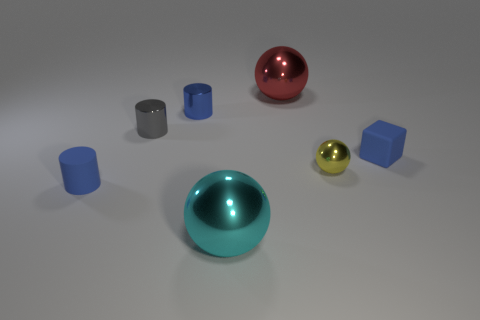What number of cyan things are either big metal blocks or big spheres?
Offer a very short reply. 1. What is the shape of the rubber thing that is the same color as the tiny rubber block?
Provide a short and direct response. Cylinder. Is there any other thing that is made of the same material as the red ball?
Your response must be concise. Yes. Do the object that is in front of the small matte cylinder and the yellow metallic thing behind the matte cylinder have the same shape?
Your answer should be compact. Yes. What number of small rubber objects are there?
Offer a terse response. 2. The large object that is made of the same material as the red ball is what shape?
Offer a terse response. Sphere. Are there any other things that are the same color as the small cube?
Give a very brief answer. Yes. There is a rubber cylinder; is it the same color as the block that is right of the tiny blue metal object?
Provide a short and direct response. Yes. Are there fewer red shiny balls in front of the red metallic object than blue shiny objects?
Ensure brevity in your answer.  Yes. There is a small blue object that is behind the blue rubber cube; what is it made of?
Your answer should be very brief. Metal. 